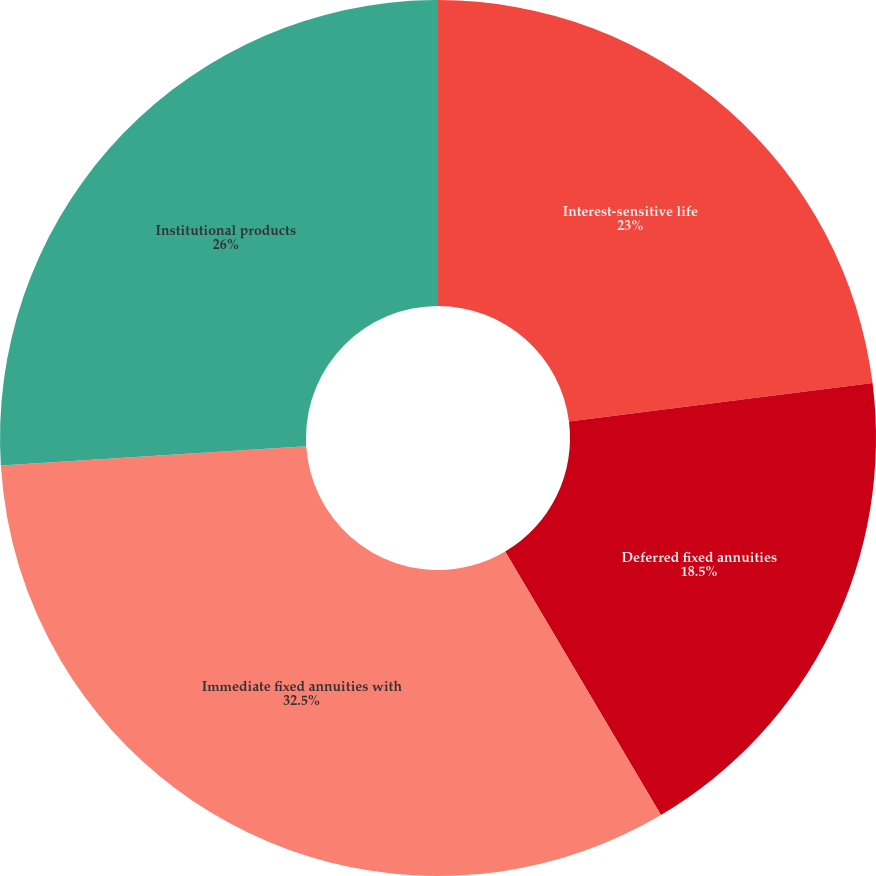Convert chart to OTSL. <chart><loc_0><loc_0><loc_500><loc_500><pie_chart><fcel>Interest-sensitive life<fcel>Deferred fixed annuities<fcel>Immediate fixed annuities with<fcel>Institutional products<nl><fcel>23.0%<fcel>18.5%<fcel>32.5%<fcel>26.0%<nl></chart> 